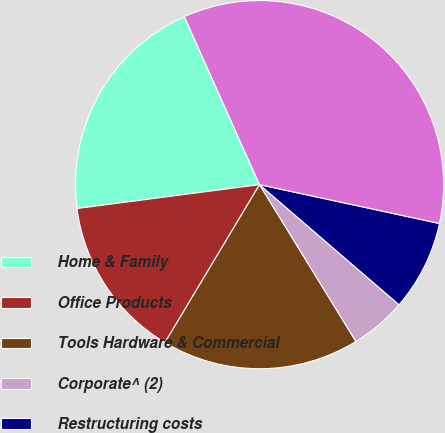<chart> <loc_0><loc_0><loc_500><loc_500><pie_chart><fcel>Home & Family<fcel>Office Products<fcel>Tools Hardware & Commercial<fcel>Corporate^ (2)<fcel>Restructuring costs<fcel>Total operating income<nl><fcel>20.37%<fcel>14.34%<fcel>17.36%<fcel>4.91%<fcel>7.93%<fcel>35.08%<nl></chart> 